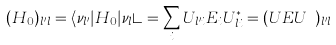<formula> <loc_0><loc_0><loc_500><loc_500>( H _ { 0 } ) _ { l ^ { \prime } l } = \langle \nu _ { l ^ { \prime } } | H _ { 0 } | \nu _ { l } \rangle = \sum _ { i } U _ { l ^ { \prime } i } E _ { i } U ^ { * } _ { l i } = ( U E U ^ { \dagger } ) _ { l ^ { \prime } l }</formula> 